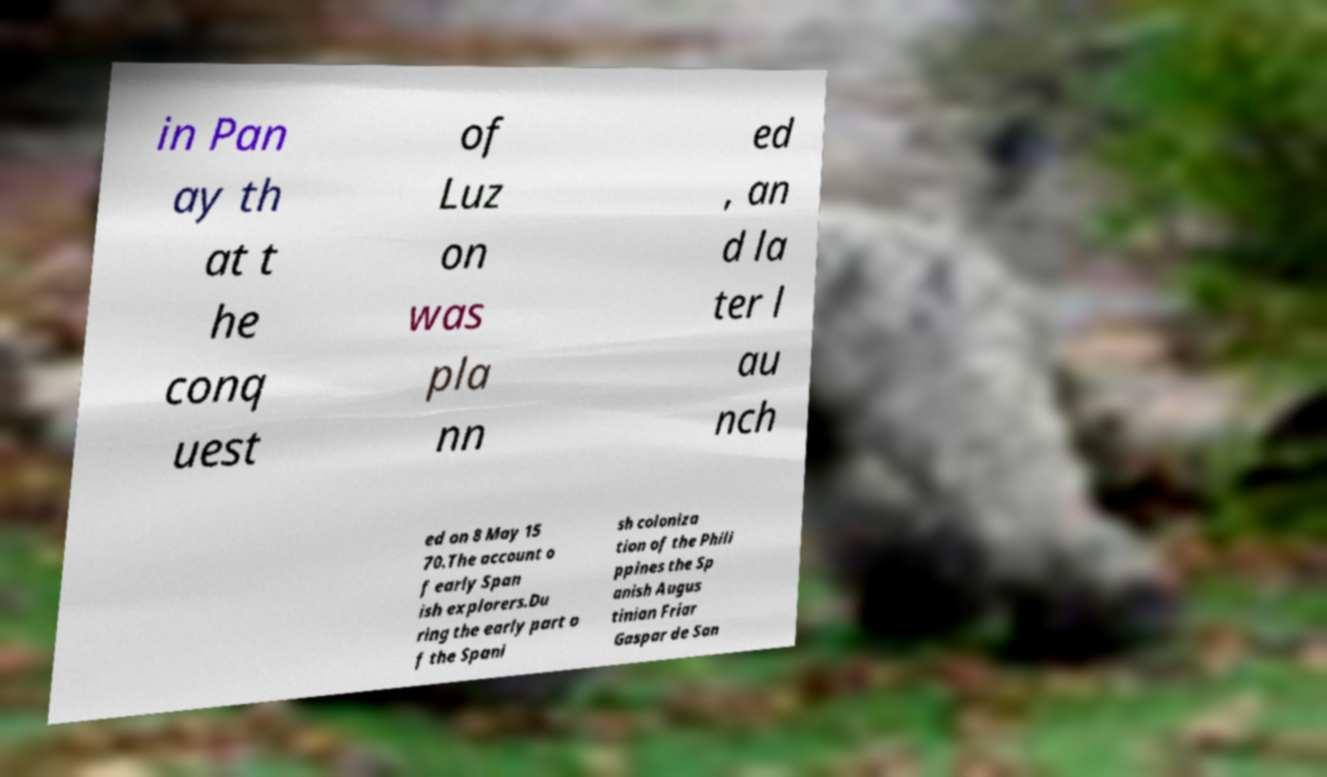Please identify and transcribe the text found in this image. in Pan ay th at t he conq uest of Luz on was pla nn ed , an d la ter l au nch ed on 8 May 15 70.The account o f early Span ish explorers.Du ring the early part o f the Spani sh coloniza tion of the Phili ppines the Sp anish Augus tinian Friar Gaspar de San 